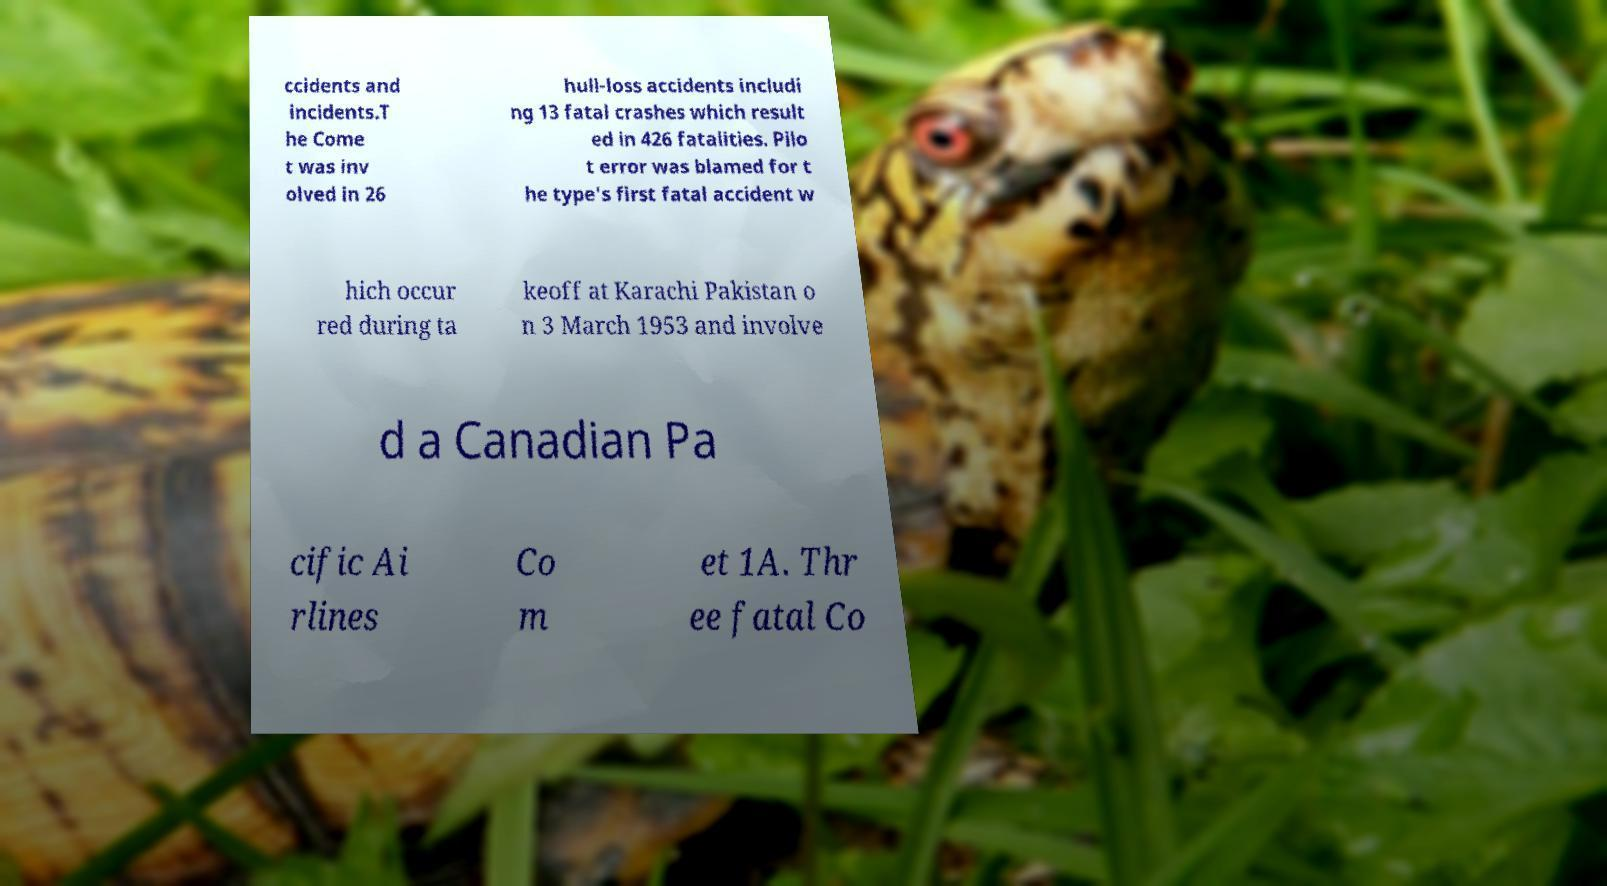Could you assist in decoding the text presented in this image and type it out clearly? ccidents and incidents.T he Come t was inv olved in 26 hull-loss accidents includi ng 13 fatal crashes which result ed in 426 fatalities. Pilo t error was blamed for t he type's first fatal accident w hich occur red during ta keoff at Karachi Pakistan o n 3 March 1953 and involve d a Canadian Pa cific Ai rlines Co m et 1A. Thr ee fatal Co 